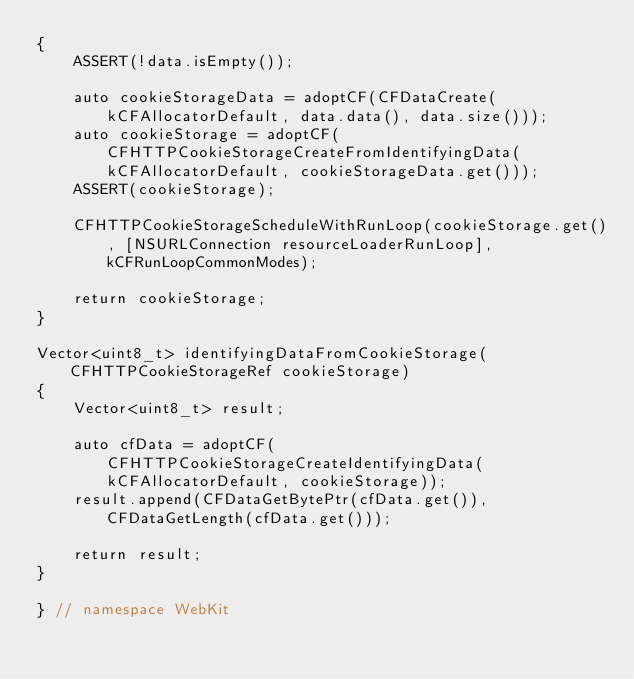<code> <loc_0><loc_0><loc_500><loc_500><_ObjectiveC_>{
    ASSERT(!data.isEmpty());

    auto cookieStorageData = adoptCF(CFDataCreate(kCFAllocatorDefault, data.data(), data.size()));
    auto cookieStorage = adoptCF(CFHTTPCookieStorageCreateFromIdentifyingData(kCFAllocatorDefault, cookieStorageData.get()));
    ASSERT(cookieStorage);

    CFHTTPCookieStorageScheduleWithRunLoop(cookieStorage.get(), [NSURLConnection resourceLoaderRunLoop], kCFRunLoopCommonModes);

    return cookieStorage;
}

Vector<uint8_t> identifyingDataFromCookieStorage(CFHTTPCookieStorageRef cookieStorage)
{
    Vector<uint8_t> result;

    auto cfData = adoptCF(CFHTTPCookieStorageCreateIdentifyingData(kCFAllocatorDefault, cookieStorage));
    result.append(CFDataGetBytePtr(cfData.get()), CFDataGetLength(cfData.get()));

    return result;
}

} // namespace WebKit
</code> 